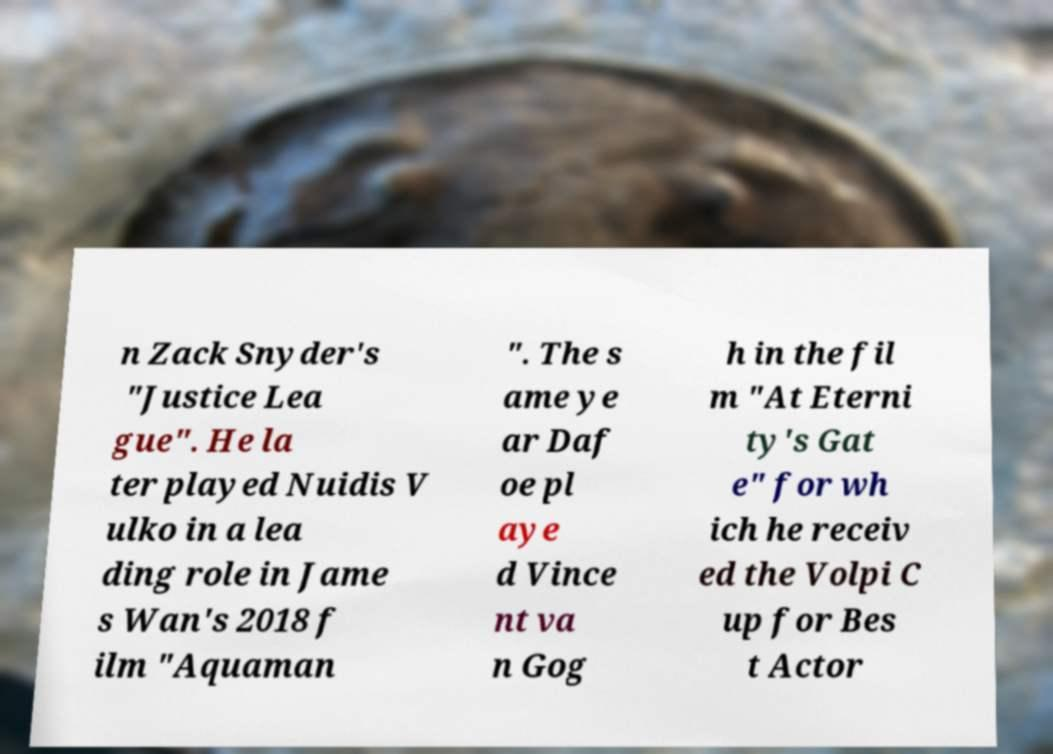Could you assist in decoding the text presented in this image and type it out clearly? n Zack Snyder's "Justice Lea gue". He la ter played Nuidis V ulko in a lea ding role in Jame s Wan's 2018 f ilm "Aquaman ". The s ame ye ar Daf oe pl aye d Vince nt va n Gog h in the fil m "At Eterni ty's Gat e" for wh ich he receiv ed the Volpi C up for Bes t Actor 